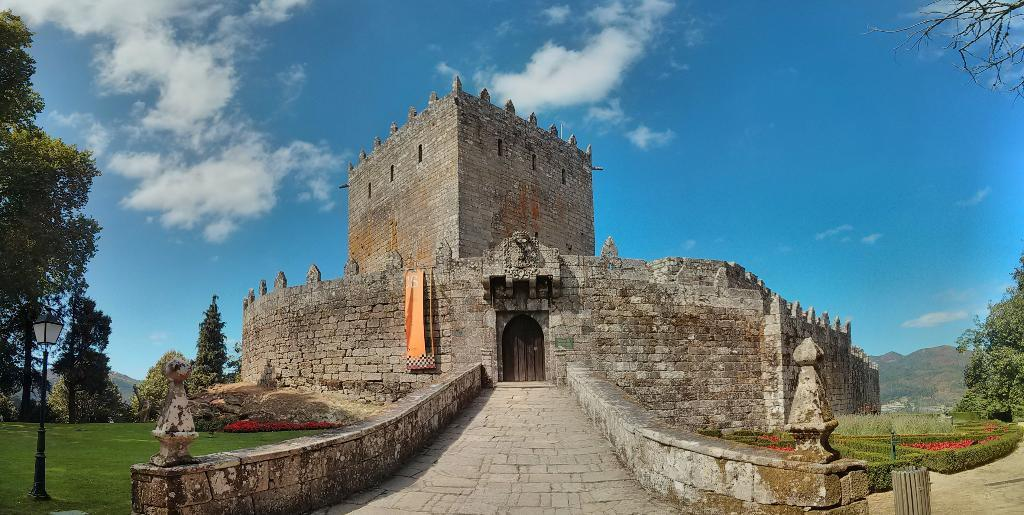What is the main subject in the center of the image? There is a building in the center of the image. What type of vegetation can be seen on the right side of the image? There are trees on the right side of the image. What type of vegetation can be seen on the left side of the image? There are trees on the left side of the image. What invention is being demonstrated in the image? There is no invention being demonstrated in the image; it primarily features a building and trees. What channel is being broadcasted in the image? There is no channel being broadcasted in the image; it is a still photograph. 